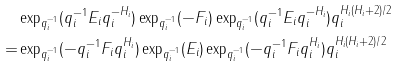<formula> <loc_0><loc_0><loc_500><loc_500>& \exp _ { q _ { i } ^ { - 1 } } ( q _ { i } ^ { - 1 } E _ { i } q _ { i } ^ { - H _ { i } } ) \exp _ { q _ { i } ^ { - 1 } } ( - F _ { i } ) \exp _ { q _ { i } ^ { - 1 } } ( q _ { i } ^ { - 1 } E _ { i } q _ { i } ^ { - H _ { i } } ) q _ { i } ^ { H _ { i } ( H _ { i } + 2 ) / 2 } \\ = & \exp _ { q _ { i } ^ { - 1 } } ( - q _ { i } ^ { - 1 } F _ { i } q _ { i } ^ { H _ { i } } ) \exp _ { q _ { i } ^ { - 1 } } ( E _ { i } ) \exp _ { q _ { i } ^ { - 1 } } ( - q _ { i } ^ { - 1 } F _ { i } q _ { i } ^ { H _ { i } } ) q _ { i } ^ { H _ { i } ( H _ { i } + 2 ) / 2 }</formula> 